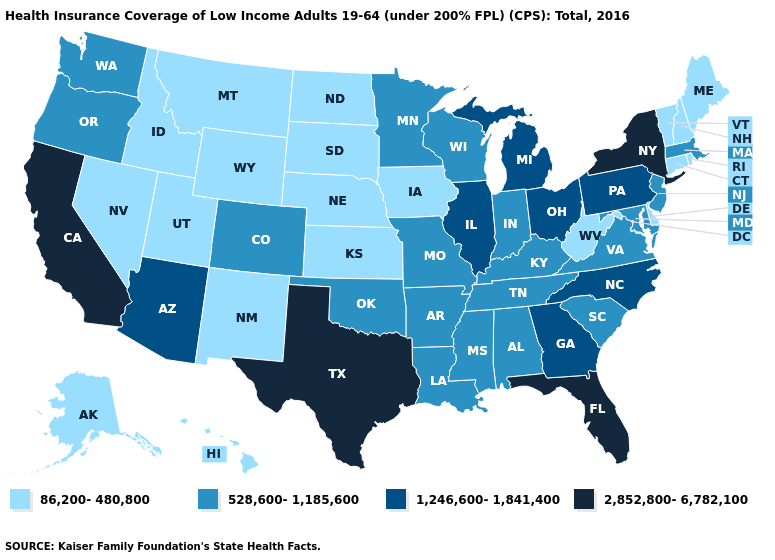What is the value of Wyoming?
Be succinct. 86,200-480,800. Does the map have missing data?
Quick response, please. No. What is the highest value in the USA?
Be succinct. 2,852,800-6,782,100. Does Iowa have the lowest value in the MidWest?
Quick response, please. Yes. Does Virginia have a higher value than Ohio?
Short answer required. No. Name the states that have a value in the range 86,200-480,800?
Write a very short answer. Alaska, Connecticut, Delaware, Hawaii, Idaho, Iowa, Kansas, Maine, Montana, Nebraska, Nevada, New Hampshire, New Mexico, North Dakota, Rhode Island, South Dakota, Utah, Vermont, West Virginia, Wyoming. Does the map have missing data?
Short answer required. No. Does Rhode Island have the same value as Illinois?
Be succinct. No. Is the legend a continuous bar?
Write a very short answer. No. Is the legend a continuous bar?
Concise answer only. No. What is the highest value in the South ?
Be succinct. 2,852,800-6,782,100. What is the highest value in states that border Massachusetts?
Answer briefly. 2,852,800-6,782,100. Which states have the highest value in the USA?
Concise answer only. California, Florida, New York, Texas. Does the first symbol in the legend represent the smallest category?
Give a very brief answer. Yes. What is the lowest value in the USA?
Quick response, please. 86,200-480,800. 